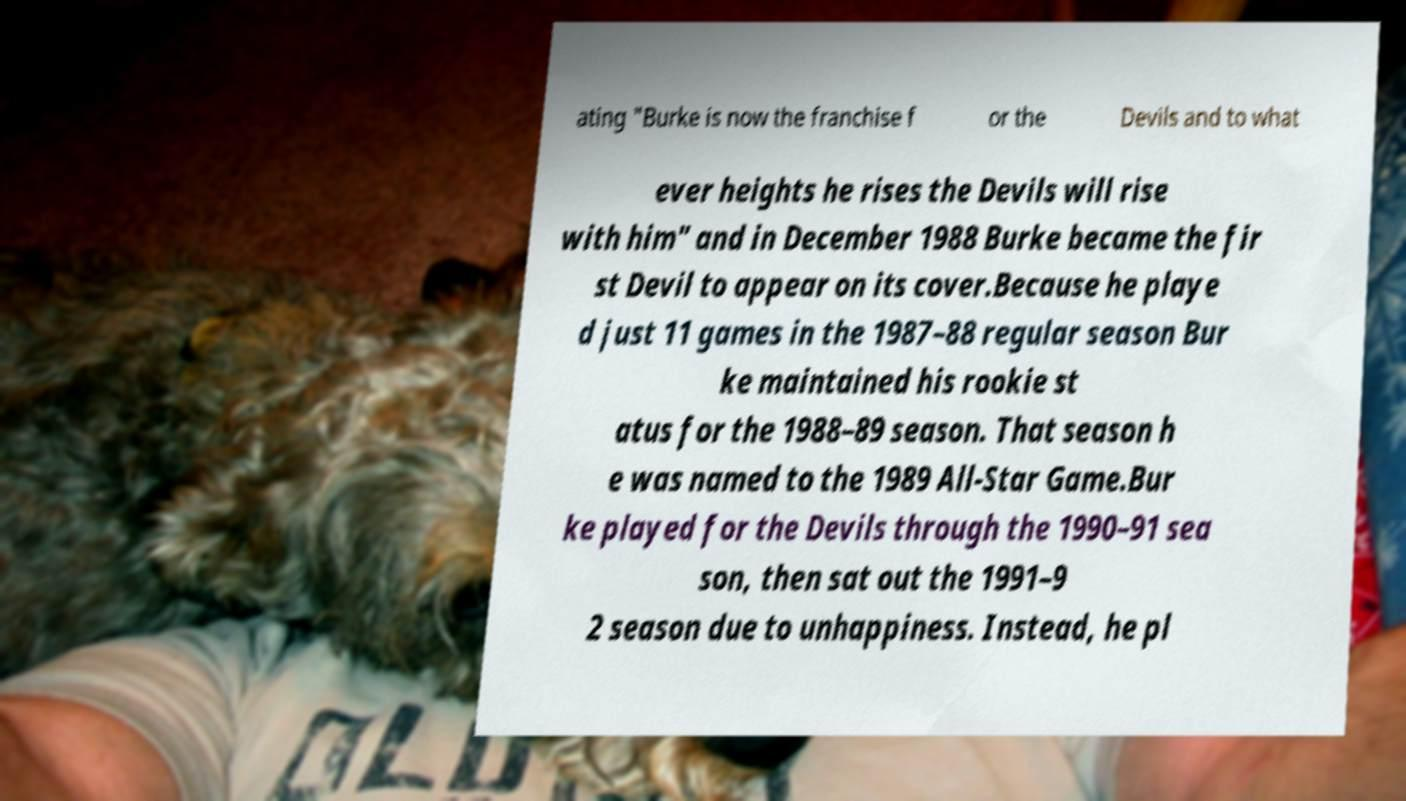There's text embedded in this image that I need extracted. Can you transcribe it verbatim? ating "Burke is now the franchise f or the Devils and to what ever heights he rises the Devils will rise with him" and in December 1988 Burke became the fir st Devil to appear on its cover.Because he playe d just 11 games in the 1987–88 regular season Bur ke maintained his rookie st atus for the 1988–89 season. That season h e was named to the 1989 All-Star Game.Bur ke played for the Devils through the 1990–91 sea son, then sat out the 1991–9 2 season due to unhappiness. Instead, he pl 